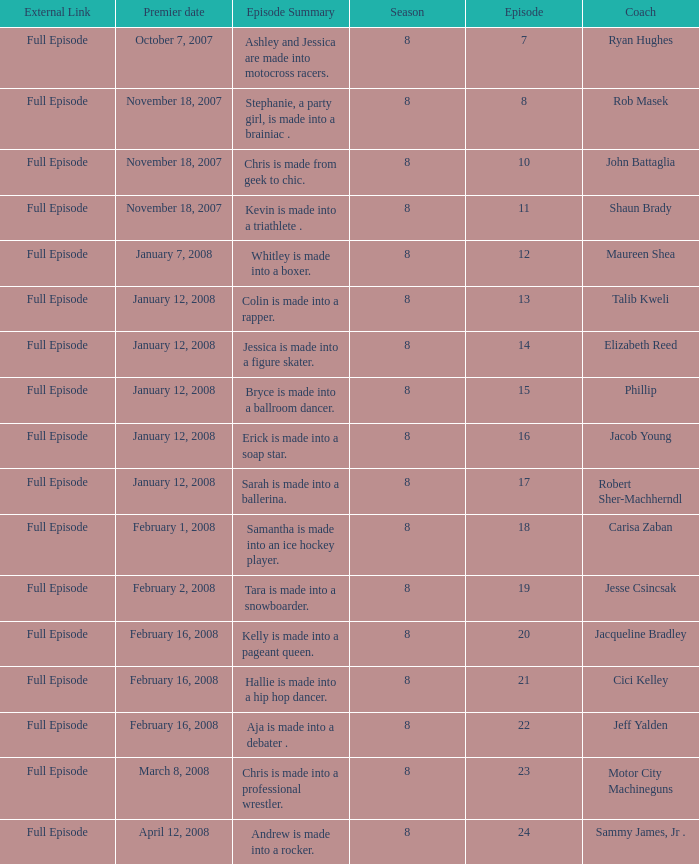What coach premiered February 16, 2008 later than episode 21.0? Jeff Yalden. 